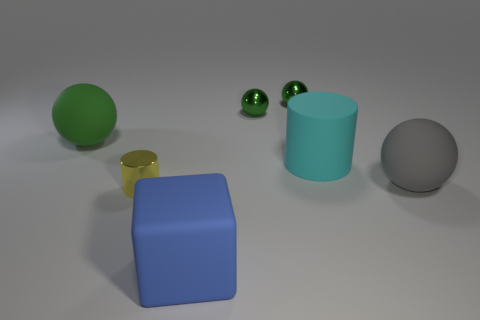Can you tell me what colors the objects in the image have? The objects in the image consist of various colors. There's a large green sphere, smaller green spheres, a blue cube, a yellow cylinder that's partially obscured, a turquoise cylinder, and a grey sphere. 